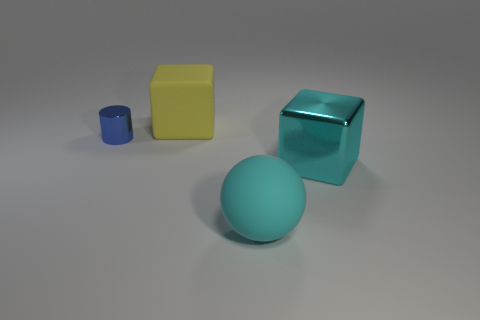Is there any other thing that is the same size as the yellow cube?
Offer a very short reply. Yes. There is a big metal object that is the same color as the ball; what is its shape?
Keep it short and to the point. Cube. The big object that is the same material as the cylinder is what shape?
Provide a short and direct response. Cube. How many objects are cyan matte balls or things that are behind the big cyan metallic object?
Provide a succinct answer. 3. Does the yellow object have the same material as the big cyan ball?
Your response must be concise. Yes. How many other things are there of the same shape as the big shiny object?
Keep it short and to the point. 1. There is a thing that is to the right of the blue shiny cylinder and left of the large cyan rubber ball; what size is it?
Give a very brief answer. Large. How many metal objects are yellow balls or blue things?
Provide a succinct answer. 1. There is a rubber object in front of the shiny cylinder; is it the same shape as the large rubber thing that is behind the shiny cylinder?
Provide a succinct answer. No. Are there any large cyan things that have the same material as the sphere?
Give a very brief answer. No. 